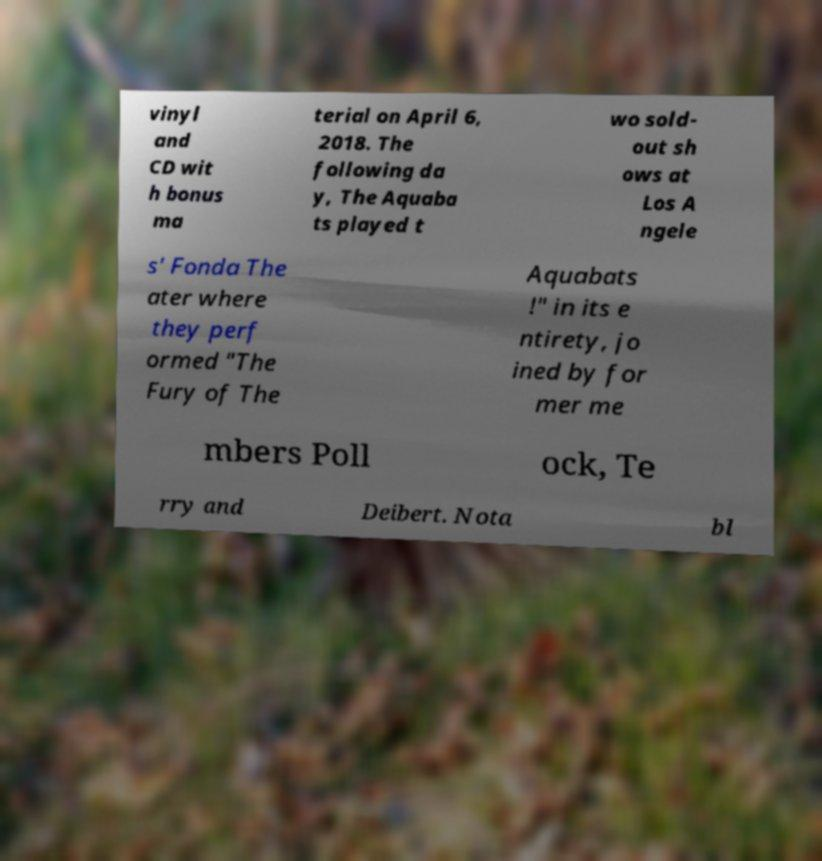For documentation purposes, I need the text within this image transcribed. Could you provide that? vinyl and CD wit h bonus ma terial on April 6, 2018. The following da y, The Aquaba ts played t wo sold- out sh ows at Los A ngele s' Fonda The ater where they perf ormed "The Fury of The Aquabats !" in its e ntirety, jo ined by for mer me mbers Poll ock, Te rry and Deibert. Nota bl 